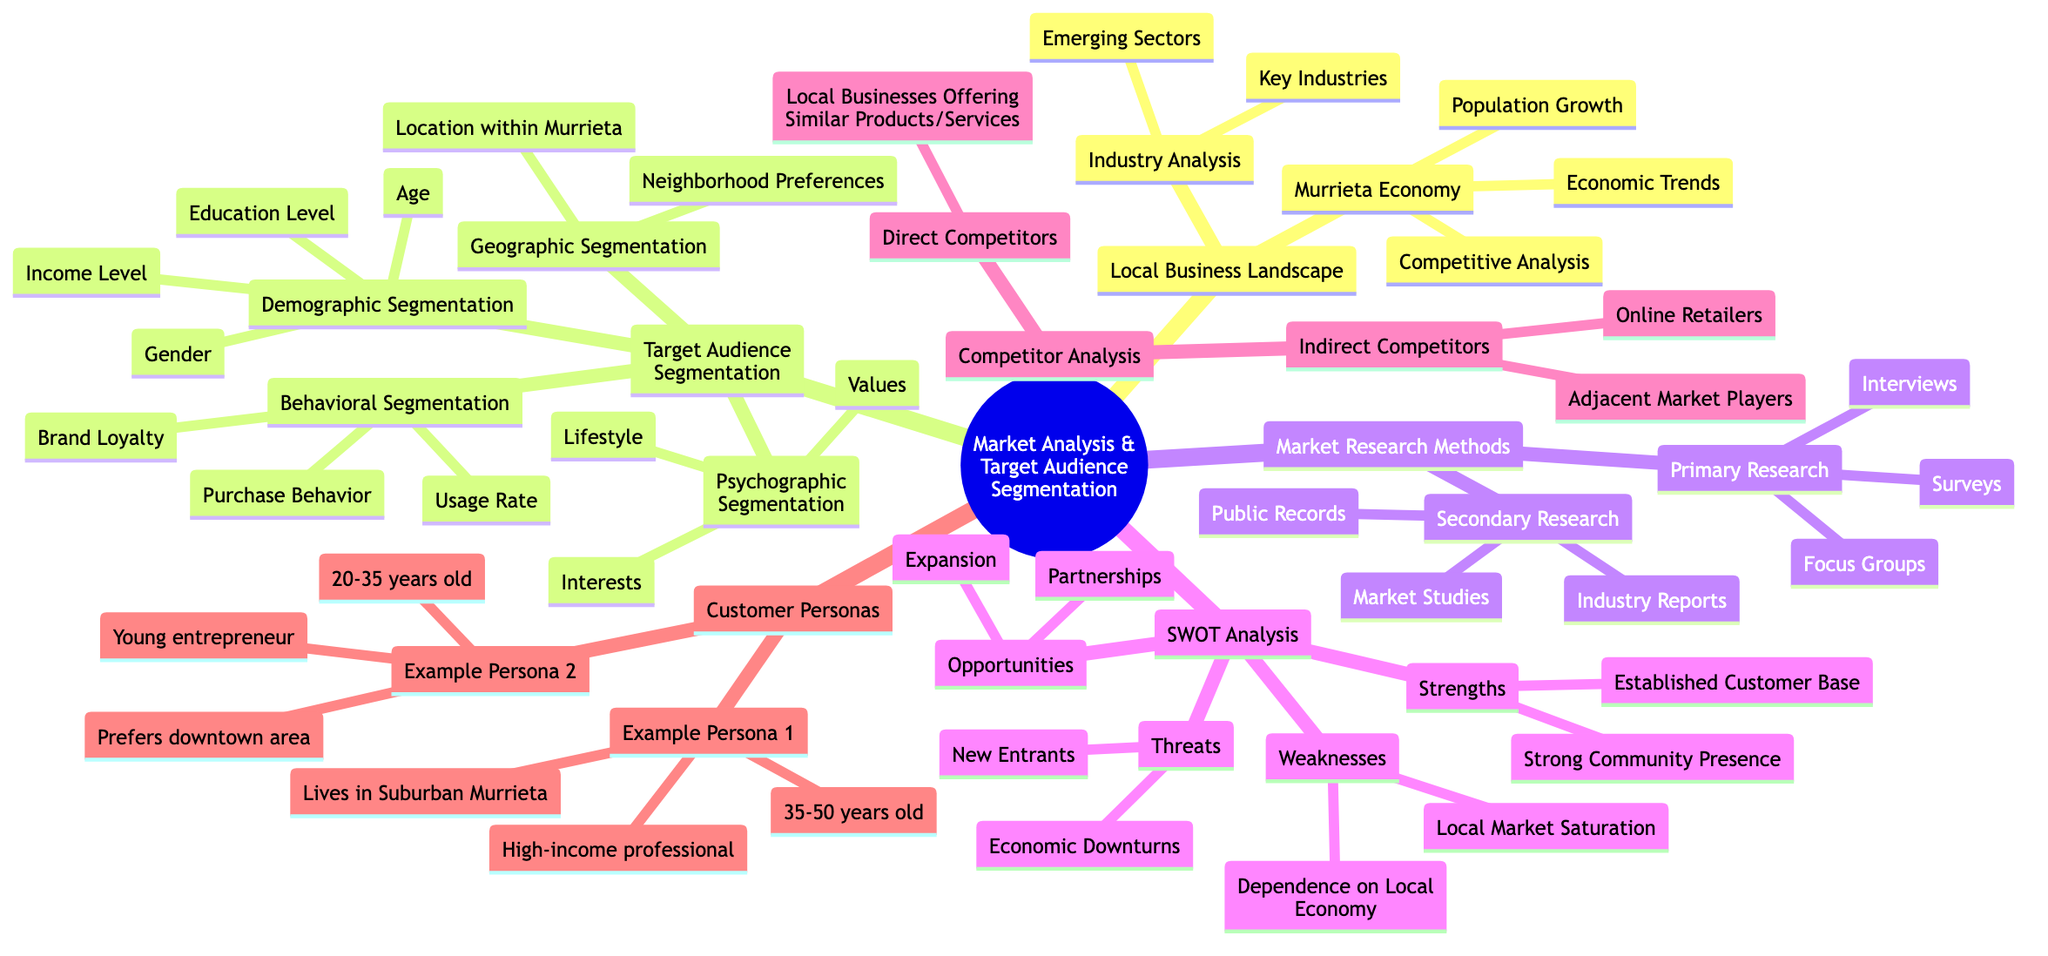What are the major areas covered under Market Analysis and Target Audience Segmentation? The diagram lists several major areas, including Local Business Landscape, Target Audience Segmentation, Market Research Methods, SWOT Analysis, Competitor Analysis, and Customer Personas.
Answer: Local Business Landscape, Target Audience Segmentation, Market Research Methods, SWOT Analysis, Competitor Analysis, Customer Personas How many types of target audience segmentation are there? From the diagram, there are four types of target audience segmentation: Demographic, Geographic, Psychographic, and Behavioral.
Answer: Four What is one of the opportunities identified in the SWOT Analysis? The diagram shows "Expansion" and "Partnerships" under opportunities. Therefore, either could be an answer.
Answer: Expansion Which age range corresponds to Example Persona 1? By looking at Example Persona 1 in the Customer Personas section of the diagram, the age range is clearly defined as 35-50 years old.
Answer: 35-50 years old What do you call competitors that offer similar products or services? According to the diagram, these competitors are labeled as Direct Competitors.
Answer: Direct Competitors Which market research method involves collecting new data directly from participants? The diagram specifies "Surveys" as one of the primary research options, which involves collecting new data directly from participants.
Answer: Surveys What is a common weakness identified in the SWOT Analysis? The diagram lists "Local Market Saturation" and "Dependence on Local Economy" as weaknesses, so either is correct.
Answer: Local Market Saturation How does Behavioral Segmentation define the target audience? Behavioral Segmentation is defined by factors such as "Purchase Behavior," "Brand Loyalty," and "Usage Rate," according to the diagram.
Answer: Purchase Behavior, Brand Loyalty, Usage Rate What is the purpose of using Customer Personas in market analysis? Customer Personas are used to understand specific characteristics of the target audience, such as demographics and preferences, which help tailor marketing strategies.
Answer: Understand characteristics of the target audience 